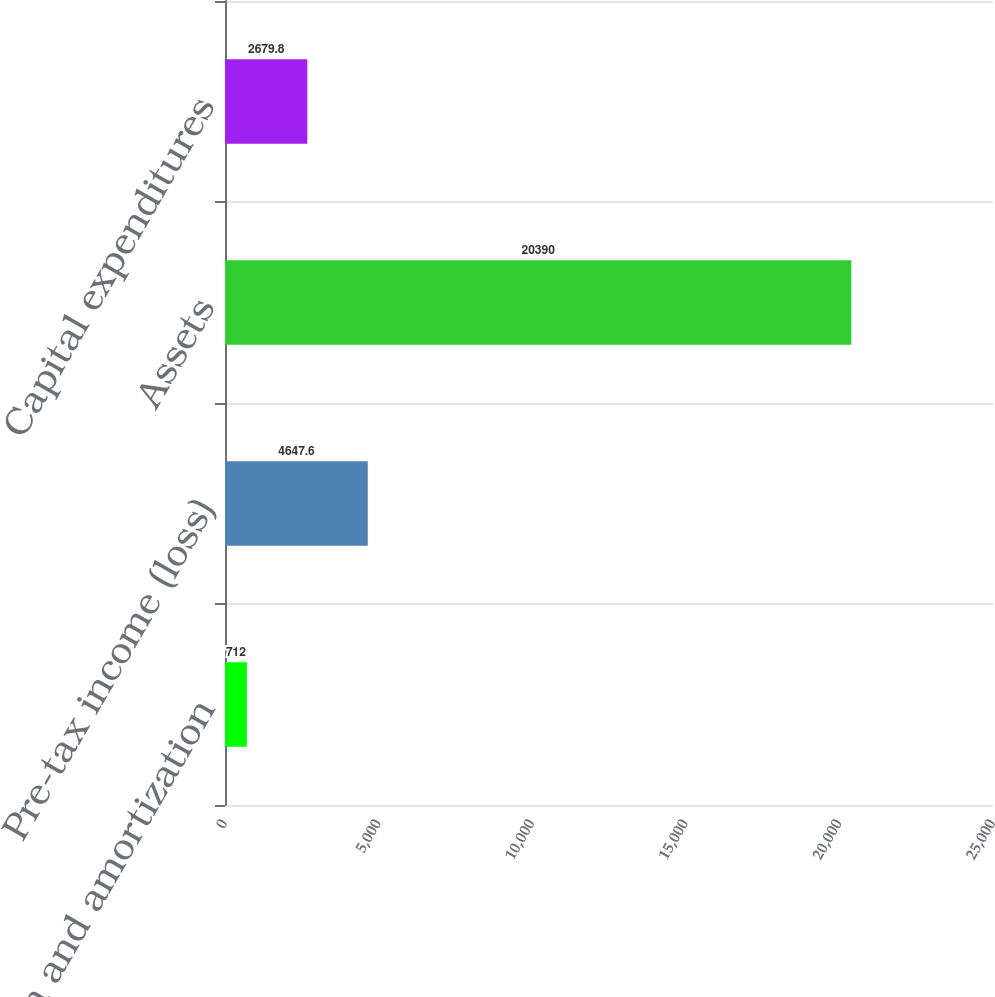Convert chart to OTSL. <chart><loc_0><loc_0><loc_500><loc_500><bar_chart><fcel>Depreciation and amortization<fcel>Pre-tax income (loss)<fcel>Assets<fcel>Capital expenditures<nl><fcel>712<fcel>4647.6<fcel>20390<fcel>2679.8<nl></chart> 